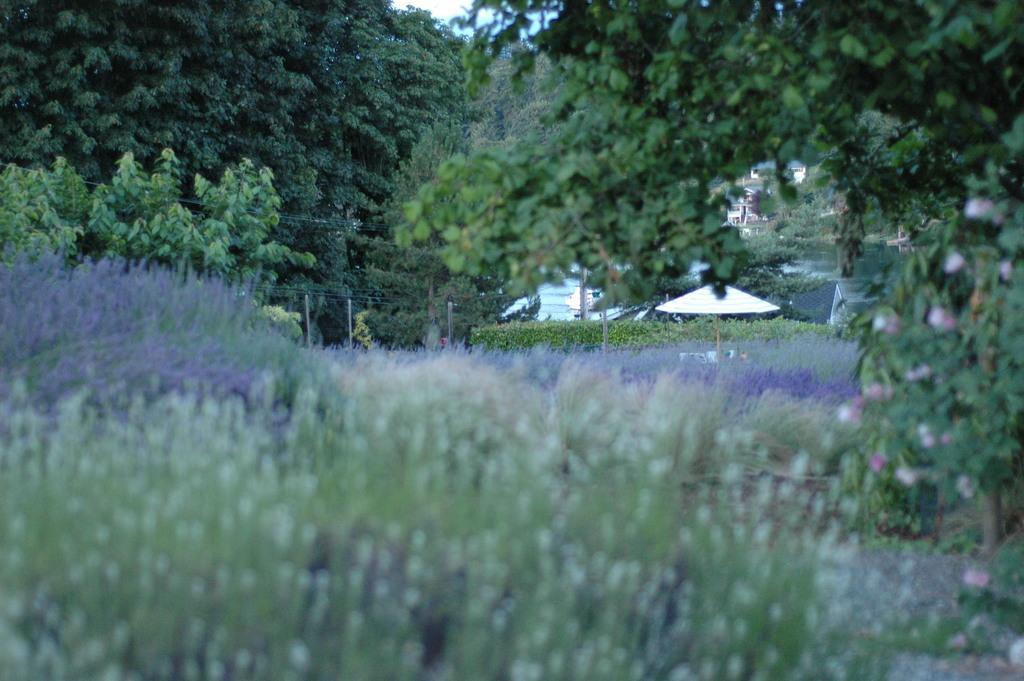Can you describe this image briefly? At the bottom we can see plants and in the background there are trees, poles, wires, tents, houses, water and sky. On the right side we can see a plant with flowers on the ground. 